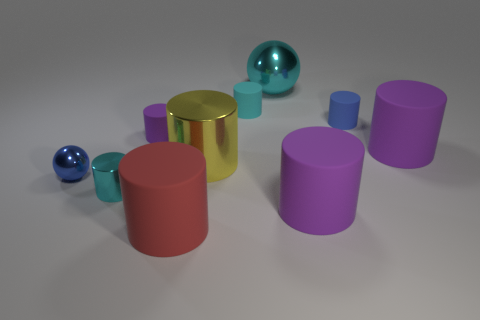Subtract all purple cylinders. How many were subtracted if there are1purple cylinders left? 2 Subtract all blue blocks. How many purple cylinders are left? 3 Subtract 4 cylinders. How many cylinders are left? 4 Subtract all yellow cylinders. How many cylinders are left? 7 Subtract all purple cylinders. How many cylinders are left? 5 Subtract all red cylinders. Subtract all brown balls. How many cylinders are left? 7 Subtract all balls. How many objects are left? 8 Add 4 large blue cylinders. How many large blue cylinders exist? 4 Subtract 0 brown cylinders. How many objects are left? 10 Subtract all small purple rubber cylinders. Subtract all tiny metallic objects. How many objects are left? 7 